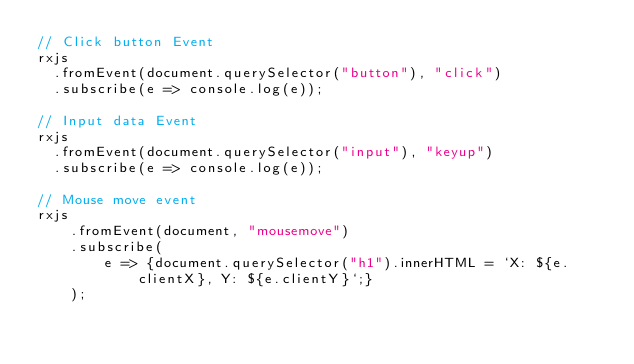<code> <loc_0><loc_0><loc_500><loc_500><_JavaScript_>// Click button Event
rxjs
  .fromEvent(document.querySelector("button"), "click")
  .subscribe(e => console.log(e));

// Input data Event
rxjs
  .fromEvent(document.querySelector("input"), "keyup")
  .subscribe(e => console.log(e));

// Mouse move event
rxjs
	.fromEvent(document, "mousemove")
	.subscribe(
		e => {document.querySelector("h1").innerHTML = `X: ${e.clientX}, Y: ${e.clientY}`;}
	);
</code> 